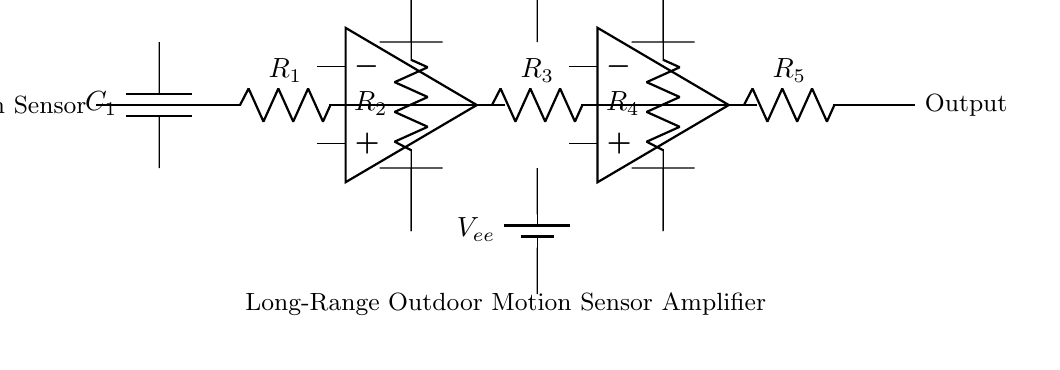What type of circuit is shown? The circuit is an amplifier circuit, as indicated by the operational amplifiers present and its purpose to amplify signals from the motion sensor.
Answer: amplifier circuit How many stages are in this amplifier circuit? The circuit contains two stages of amplification, each represented by an operational amplifier block.
Answer: two What component is used to couple the first stage to the second stage? The second stage is connected to the first stage through a resistor, specifically R3, which allows for the amplified signal to pass through.
Answer: R3 What is the purpose of the capacitors in this circuit? The capacitor (C1) serves to filter or stabilize the input signal from the motion sensor, improving the performance of the amplifier stages.
Answer: filter What is the role of the resistors in the circuit? The resistors (R1, R2, R3, R4, R5) are used for setting the gain of the amplifiers and controlling the signal levels at different locations in the circuit.
Answer: gain setting What are the supply voltages used for the amplifiers? The supply voltages are labeled as Vcc (for positive supply) and Vee (for negative supply), providing the necessary power for the operational amplifiers to function.
Answer: Vcc and Vee What is the output of this circuit? The output of the circuit is a signal that represents the amplified response from the motion sensor, which is labeled as "Output."
Answer: Output 